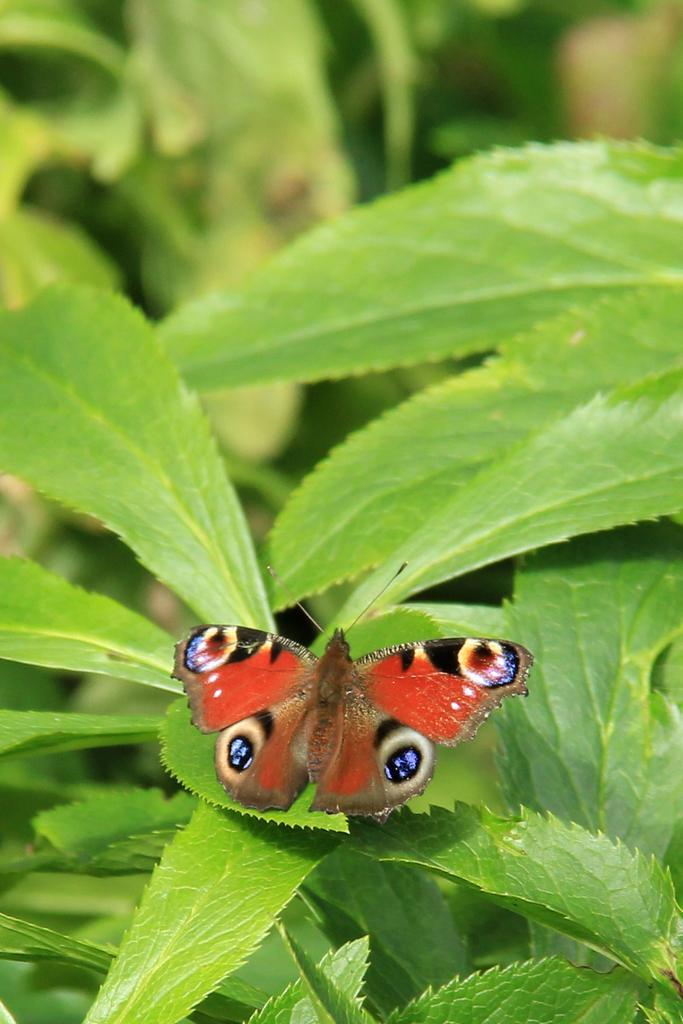How would you summarize this image in a sentence or two? In this image in the middle there is a beautiful butterfly. In the background there is a plant and leaves. 